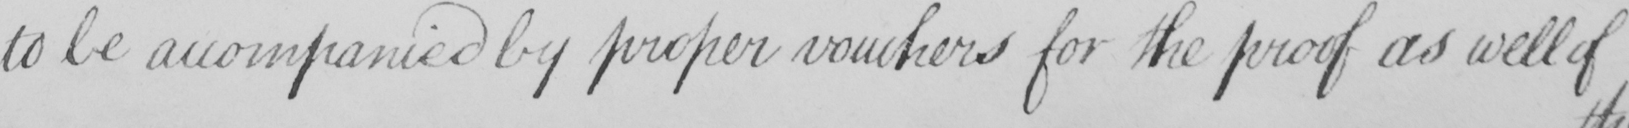What text is written in this handwritten line? to be accompanied by proper vouchers for the proof as well of 